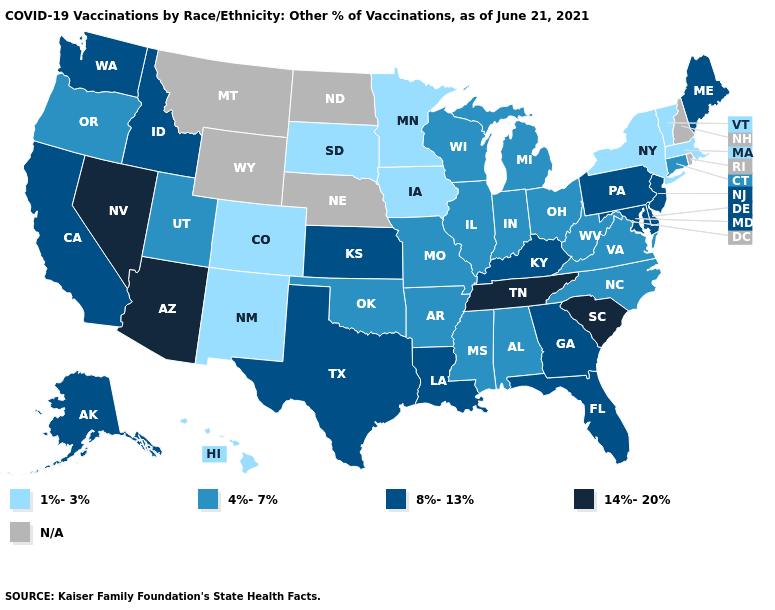Which states have the highest value in the USA?
Answer briefly. Arizona, Nevada, South Carolina, Tennessee. Which states have the highest value in the USA?
Concise answer only. Arizona, Nevada, South Carolina, Tennessee. What is the lowest value in the USA?
Concise answer only. 1%-3%. Does Virginia have the lowest value in the USA?
Concise answer only. No. How many symbols are there in the legend?
Write a very short answer. 5. Name the states that have a value in the range 8%-13%?
Quick response, please. Alaska, California, Delaware, Florida, Georgia, Idaho, Kansas, Kentucky, Louisiana, Maine, Maryland, New Jersey, Pennsylvania, Texas, Washington. Does Tennessee have the highest value in the USA?
Concise answer only. Yes. Does the first symbol in the legend represent the smallest category?
Answer briefly. Yes. Which states hav the highest value in the South?
Short answer required. South Carolina, Tennessee. Does the map have missing data?
Give a very brief answer. Yes. What is the highest value in states that border Alabama?
Quick response, please. 14%-20%. What is the value of Florida?
Be succinct. 8%-13%. 